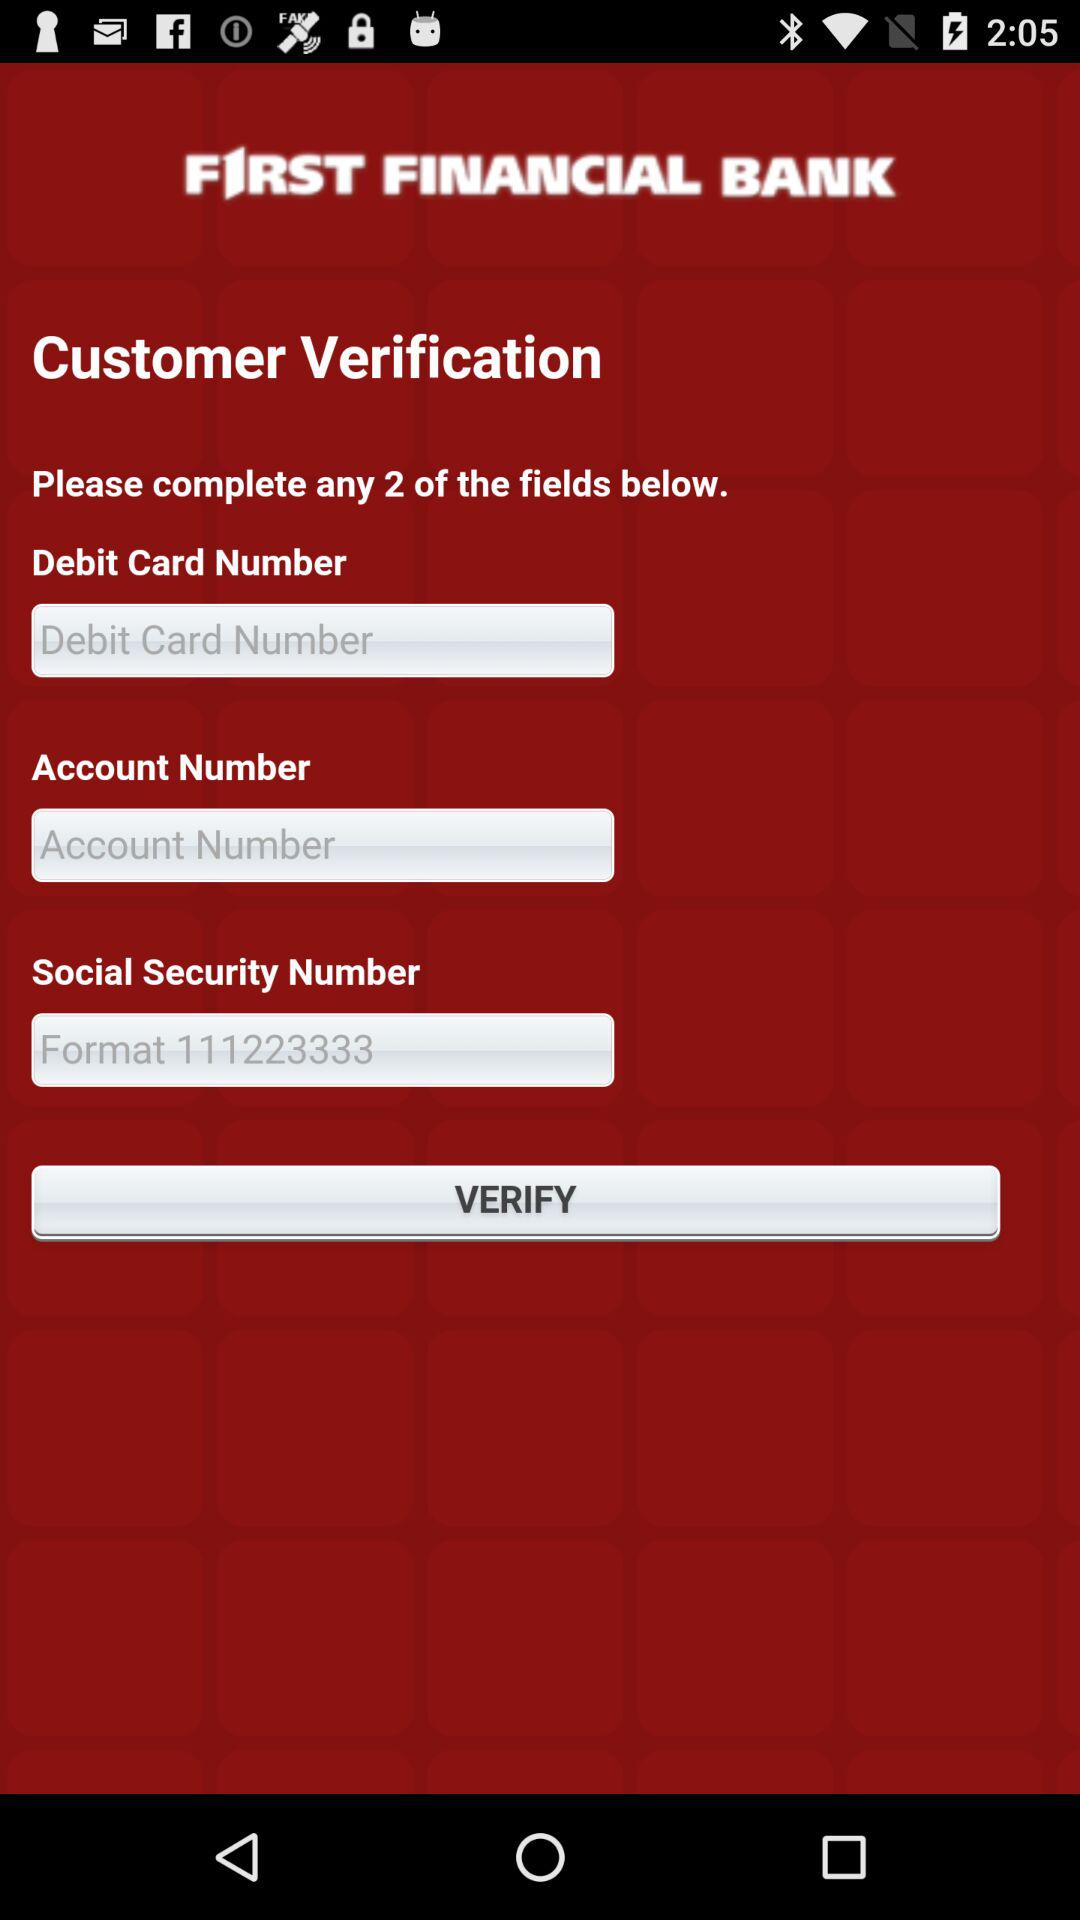How many fields are there for entering information?
Answer the question using a single word or phrase. 3 